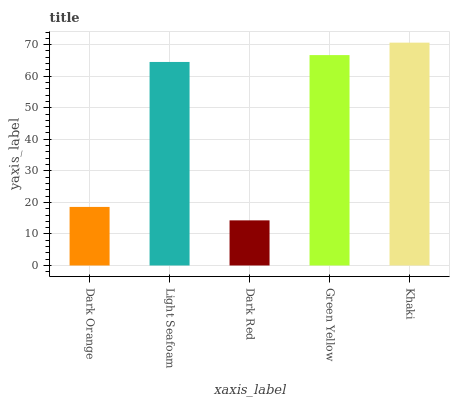Is Dark Red the minimum?
Answer yes or no. Yes. Is Khaki the maximum?
Answer yes or no. Yes. Is Light Seafoam the minimum?
Answer yes or no. No. Is Light Seafoam the maximum?
Answer yes or no. No. Is Light Seafoam greater than Dark Orange?
Answer yes or no. Yes. Is Dark Orange less than Light Seafoam?
Answer yes or no. Yes. Is Dark Orange greater than Light Seafoam?
Answer yes or no. No. Is Light Seafoam less than Dark Orange?
Answer yes or no. No. Is Light Seafoam the high median?
Answer yes or no. Yes. Is Light Seafoam the low median?
Answer yes or no. Yes. Is Green Yellow the high median?
Answer yes or no. No. Is Green Yellow the low median?
Answer yes or no. No. 